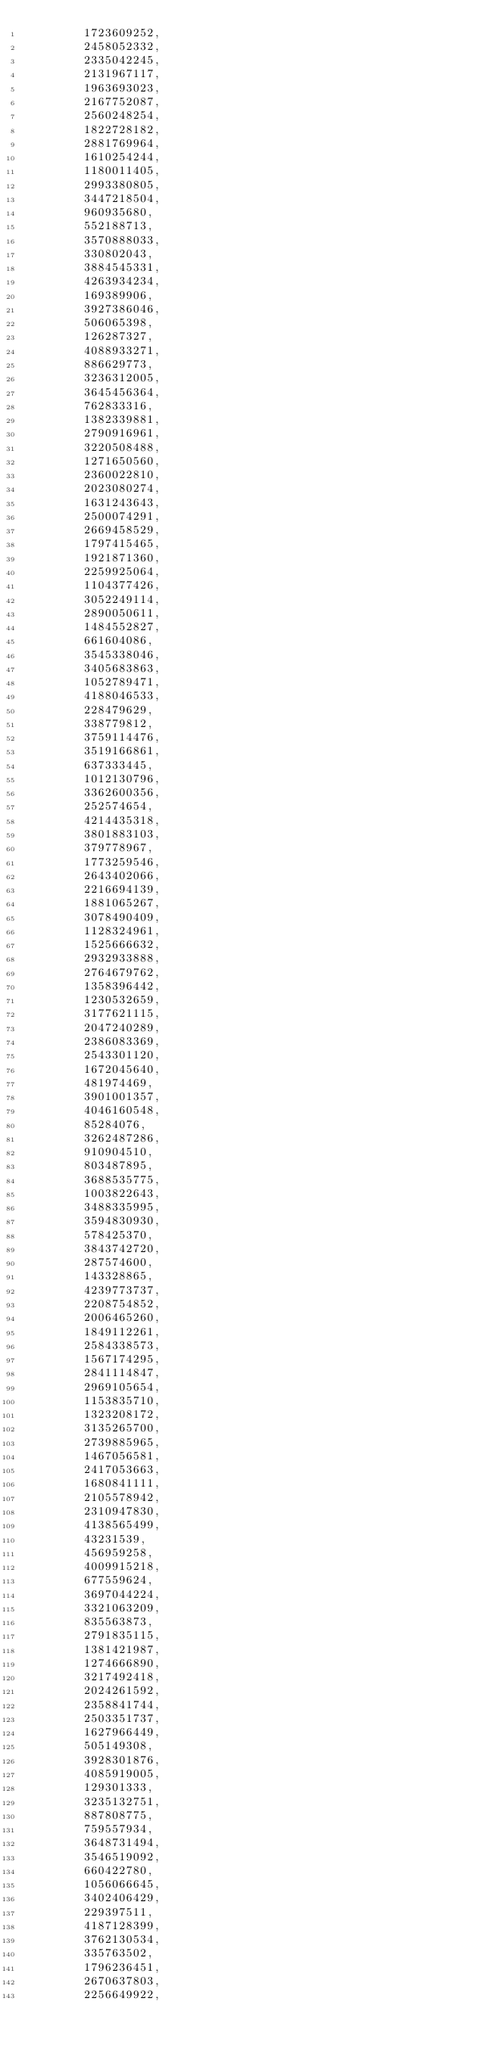<code> <loc_0><loc_0><loc_500><loc_500><_Rust_>        1723609252,
        2458052332,
        2335042245,
        2131967117,
        1963693023,
        2167752087,
        2560248254,
        1822728182,
        2881769964,
        1610254244,
        1180011405,
        2993380805,
        3447218504,
        960935680,
        552188713,
        3570888033,
        330802043,
        3884545331,
        4263934234,
        169389906,
        3927386046,
        506065398,
        126287327,
        4088933271,
        886629773,
        3236312005,
        3645456364,
        762833316,
        1382339881,
        2790916961,
        3220508488,
        1271650560,
        2360022810,
        2023080274,
        1631243643,
        2500074291,
        2669458529,
        1797415465,
        1921871360,
        2259925064,
        1104377426,
        3052249114,
        2890050611,
        1484552827,
        661604086,
        3545338046,
        3405683863,
        1052789471,
        4188046533,
        228479629,
        338779812,
        3759114476,
        3519166861,
        637333445,
        1012130796,
        3362600356,
        252574654,
        4214435318,
        3801883103,
        379778967,
        1773259546,
        2643402066,
        2216694139,
        1881065267,
        3078490409,
        1128324961,
        1525666632,
        2932933888,
        2764679762,
        1358396442,
        1230532659,
        3177621115,
        2047240289,
        2386083369,
        2543301120,
        1672045640,
        481974469,
        3901001357,
        4046160548,
        85284076,
        3262487286,
        910904510,
        803487895,
        3688535775,
        1003822643,
        3488335995,
        3594830930,
        578425370,
        3843742720,
        287574600,
        143328865,
        4239773737,
        2208754852,
        2006465260,
        1849112261,
        2584338573,
        1567174295,
        2841114847,
        2969105654,
        1153835710,
        1323208172,
        3135265700,
        2739885965,
        1467056581,
        2417053663,
        1680841111,
        2105578942,
        2310947830,
        4138565499,
        43231539,
        456959258,
        4009915218,
        677559624,
        3697044224,
        3321063209,
        835563873,
        2791835115,
        1381421987,
        1274666890,
        3217492418,
        2024261592,
        2358841744,
        2503351737,
        1627966449,
        505149308,
        3928301876,
        4085919005,
        129301333,
        3235132751,
        887808775,
        759557934,
        3648731494,
        3546519092,
        660422780,
        1056066645,
        3402406429,
        229397511,
        4187128399,
        3762130534,
        335763502,
        1796236451,
        2670637803,
        2256649922,</code> 